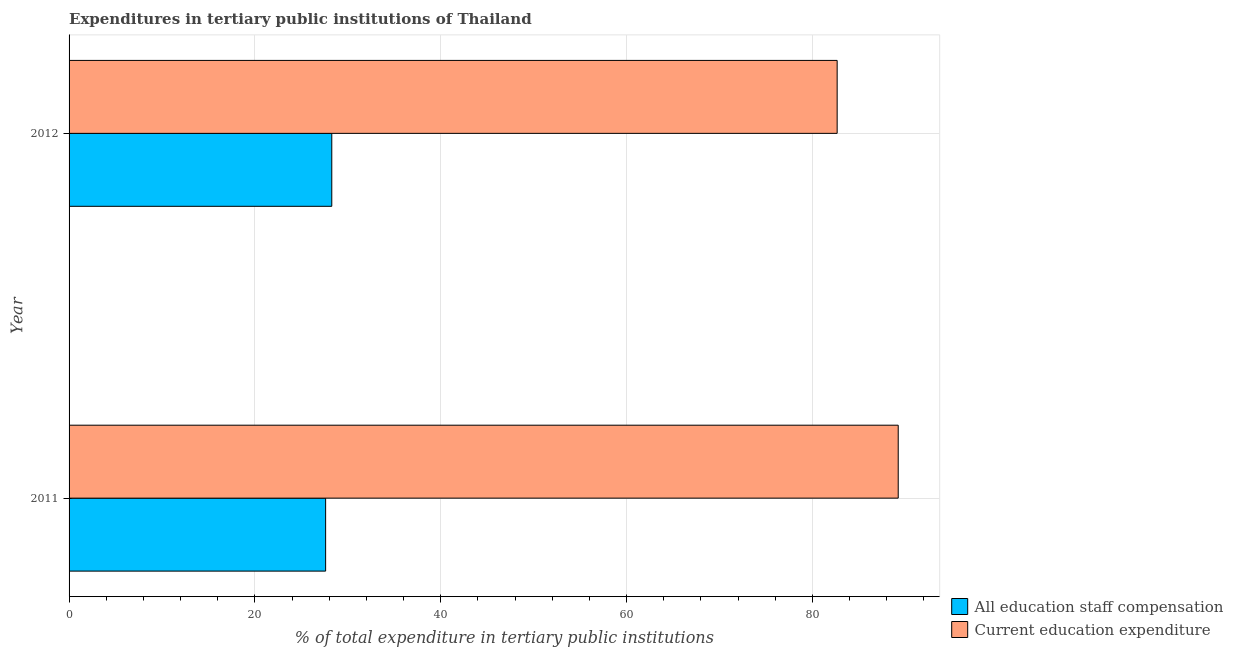How many different coloured bars are there?
Provide a short and direct response. 2. Are the number of bars on each tick of the Y-axis equal?
Provide a succinct answer. Yes. How many bars are there on the 1st tick from the bottom?
Offer a terse response. 2. What is the label of the 2nd group of bars from the top?
Your answer should be very brief. 2011. In how many cases, is the number of bars for a given year not equal to the number of legend labels?
Make the answer very short. 0. What is the expenditure in education in 2012?
Keep it short and to the point. 82.67. Across all years, what is the maximum expenditure in staff compensation?
Your response must be concise. 28.27. Across all years, what is the minimum expenditure in staff compensation?
Ensure brevity in your answer.  27.61. What is the total expenditure in education in the graph?
Provide a short and direct response. 171.9. What is the difference between the expenditure in staff compensation in 2011 and that in 2012?
Provide a short and direct response. -0.66. What is the difference between the expenditure in education in 2011 and the expenditure in staff compensation in 2012?
Give a very brief answer. 60.96. What is the average expenditure in staff compensation per year?
Offer a very short reply. 27.94. In the year 2011, what is the difference between the expenditure in education and expenditure in staff compensation?
Give a very brief answer. 61.63. In how many years, is the expenditure in staff compensation greater than 16 %?
Ensure brevity in your answer.  2. What is the ratio of the expenditure in staff compensation in 2011 to that in 2012?
Provide a short and direct response. 0.98. Is the difference between the expenditure in education in 2011 and 2012 greater than the difference between the expenditure in staff compensation in 2011 and 2012?
Provide a succinct answer. Yes. What does the 1st bar from the top in 2011 represents?
Give a very brief answer. Current education expenditure. What does the 1st bar from the bottom in 2012 represents?
Your answer should be compact. All education staff compensation. What is the difference between two consecutive major ticks on the X-axis?
Your answer should be compact. 20. Are the values on the major ticks of X-axis written in scientific E-notation?
Give a very brief answer. No. How many legend labels are there?
Offer a very short reply. 2. How are the legend labels stacked?
Your response must be concise. Vertical. What is the title of the graph?
Provide a succinct answer. Expenditures in tertiary public institutions of Thailand. What is the label or title of the X-axis?
Provide a short and direct response. % of total expenditure in tertiary public institutions. What is the label or title of the Y-axis?
Ensure brevity in your answer.  Year. What is the % of total expenditure in tertiary public institutions of All education staff compensation in 2011?
Provide a succinct answer. 27.61. What is the % of total expenditure in tertiary public institutions of Current education expenditure in 2011?
Give a very brief answer. 89.24. What is the % of total expenditure in tertiary public institutions of All education staff compensation in 2012?
Provide a short and direct response. 28.27. What is the % of total expenditure in tertiary public institutions in Current education expenditure in 2012?
Provide a succinct answer. 82.67. Across all years, what is the maximum % of total expenditure in tertiary public institutions in All education staff compensation?
Make the answer very short. 28.27. Across all years, what is the maximum % of total expenditure in tertiary public institutions in Current education expenditure?
Your answer should be very brief. 89.24. Across all years, what is the minimum % of total expenditure in tertiary public institutions of All education staff compensation?
Offer a very short reply. 27.61. Across all years, what is the minimum % of total expenditure in tertiary public institutions in Current education expenditure?
Give a very brief answer. 82.67. What is the total % of total expenditure in tertiary public institutions in All education staff compensation in the graph?
Your answer should be very brief. 55.89. What is the total % of total expenditure in tertiary public institutions in Current education expenditure in the graph?
Offer a terse response. 171.9. What is the difference between the % of total expenditure in tertiary public institutions of All education staff compensation in 2011 and that in 2012?
Keep it short and to the point. -0.66. What is the difference between the % of total expenditure in tertiary public institutions in Current education expenditure in 2011 and that in 2012?
Your answer should be very brief. 6.57. What is the difference between the % of total expenditure in tertiary public institutions of All education staff compensation in 2011 and the % of total expenditure in tertiary public institutions of Current education expenditure in 2012?
Your answer should be very brief. -55.05. What is the average % of total expenditure in tertiary public institutions of All education staff compensation per year?
Make the answer very short. 27.94. What is the average % of total expenditure in tertiary public institutions of Current education expenditure per year?
Your answer should be very brief. 85.95. In the year 2011, what is the difference between the % of total expenditure in tertiary public institutions of All education staff compensation and % of total expenditure in tertiary public institutions of Current education expenditure?
Give a very brief answer. -61.63. In the year 2012, what is the difference between the % of total expenditure in tertiary public institutions of All education staff compensation and % of total expenditure in tertiary public institutions of Current education expenditure?
Offer a terse response. -54.39. What is the ratio of the % of total expenditure in tertiary public institutions in All education staff compensation in 2011 to that in 2012?
Provide a short and direct response. 0.98. What is the ratio of the % of total expenditure in tertiary public institutions of Current education expenditure in 2011 to that in 2012?
Offer a very short reply. 1.08. What is the difference between the highest and the second highest % of total expenditure in tertiary public institutions of All education staff compensation?
Offer a terse response. 0.66. What is the difference between the highest and the second highest % of total expenditure in tertiary public institutions in Current education expenditure?
Your response must be concise. 6.57. What is the difference between the highest and the lowest % of total expenditure in tertiary public institutions in All education staff compensation?
Keep it short and to the point. 0.66. What is the difference between the highest and the lowest % of total expenditure in tertiary public institutions in Current education expenditure?
Your answer should be compact. 6.57. 